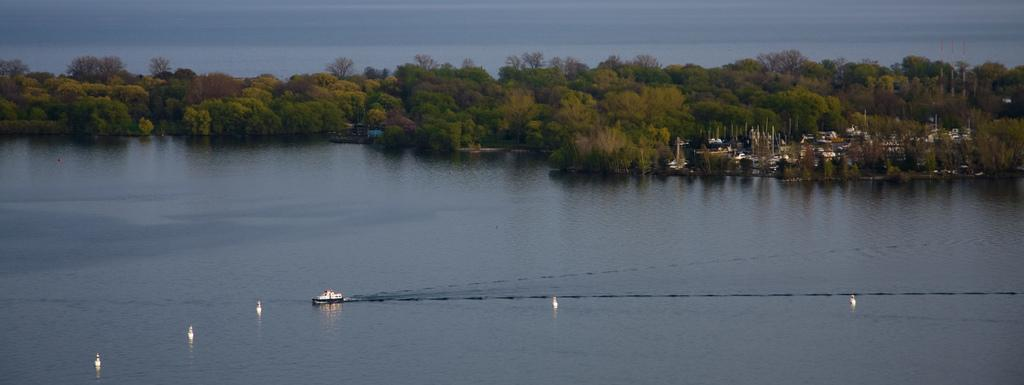What is the main subject of the image? The main subject of the image is a boat. Where is the boat located? The boat is on the water. What can be seen in the background of the image? There are trees and other boats visible in the background of the image. What type of treatment is being administered to the boat in the image? There is no treatment being administered to the boat in the image; it is simply floating on the water. Can you see a pail being used by someone on the boat in the image? There is no pail visible in the image. 